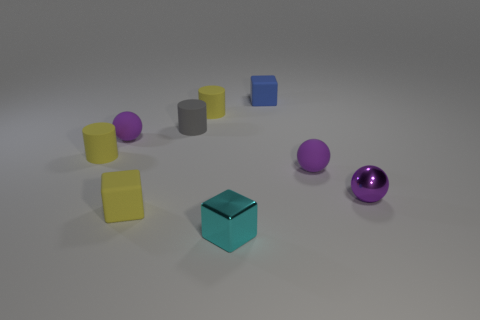Can you tell me which objects are the same shape as the small blue block? Certainly, the small blue block is a cube and the gray object located near the center of the image is also a cube, sharing the same shape. 